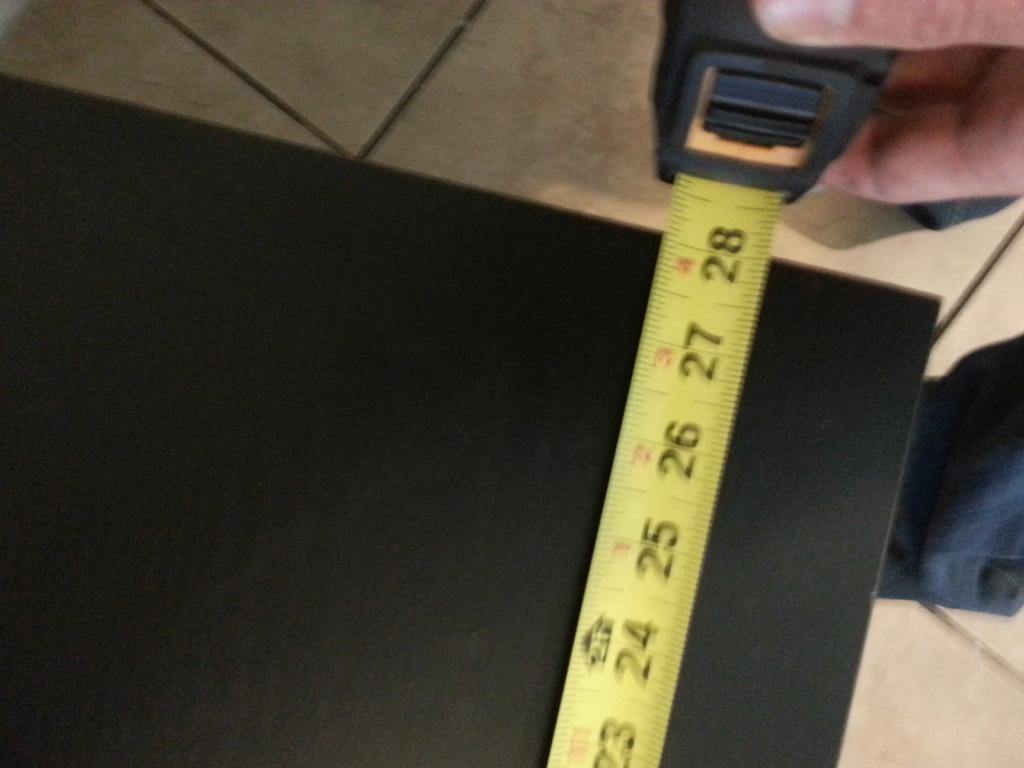How many full inches is the tape measure extended?
Ensure brevity in your answer.  28. What is the number on the bottom of the measure?
Your answer should be very brief. 28. 